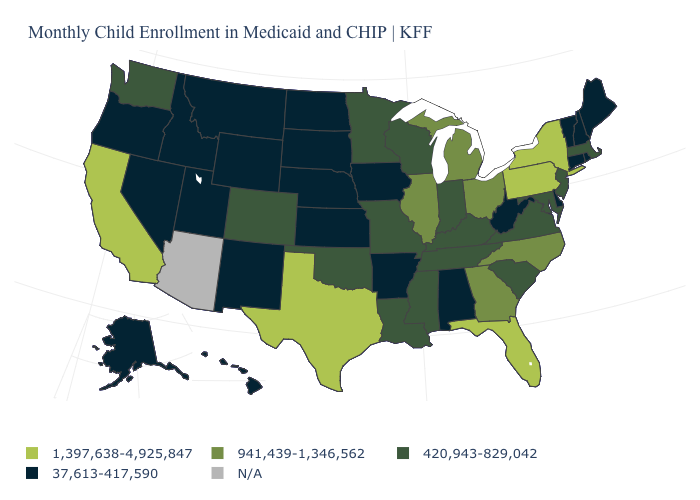Name the states that have a value in the range N/A?
Be succinct. Arizona. What is the value of Iowa?
Answer briefly. 37,613-417,590. What is the value of Minnesota?
Write a very short answer. 420,943-829,042. Is the legend a continuous bar?
Keep it brief. No. What is the value of Maine?
Be succinct. 37,613-417,590. Name the states that have a value in the range N/A?
Keep it brief. Arizona. Name the states that have a value in the range 37,613-417,590?
Short answer required. Alabama, Alaska, Arkansas, Connecticut, Delaware, Hawaii, Idaho, Iowa, Kansas, Maine, Montana, Nebraska, Nevada, New Hampshire, New Mexico, North Dakota, Oregon, Rhode Island, South Dakota, Utah, Vermont, West Virginia, Wyoming. What is the highest value in the MidWest ?
Be succinct. 941,439-1,346,562. What is the value of Nevada?
Concise answer only. 37,613-417,590. Does Maryland have the lowest value in the USA?
Write a very short answer. No. What is the value of Oklahoma?
Concise answer only. 420,943-829,042. What is the lowest value in the USA?
Be succinct. 37,613-417,590. Which states have the highest value in the USA?
Answer briefly. California, Florida, New York, Pennsylvania, Texas. What is the highest value in the South ?
Keep it brief. 1,397,638-4,925,847. 